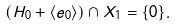Convert formula to latex. <formula><loc_0><loc_0><loc_500><loc_500>( H _ { 0 } + \langle e _ { 0 } \rangle ) \cap X _ { 1 } = \{ 0 \} .</formula> 